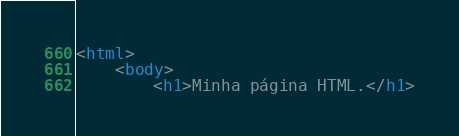<code> <loc_0><loc_0><loc_500><loc_500><_HTML_><html>
    <body>
        <h1>Minha página HTML.</h1></code> 